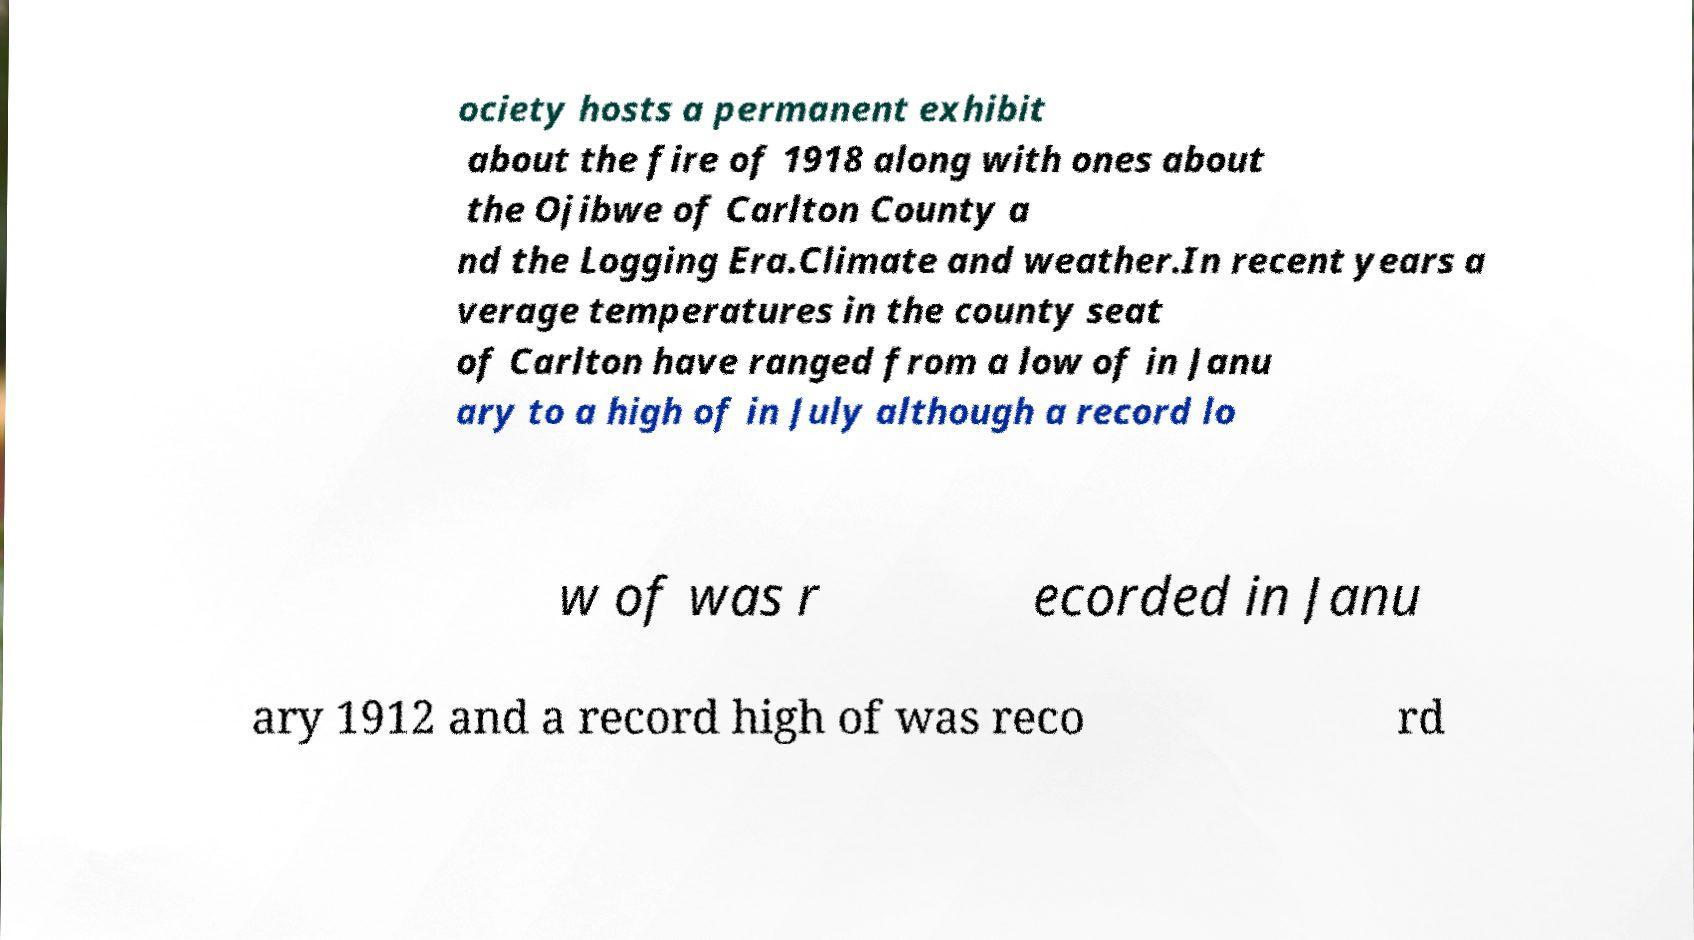Can you read and provide the text displayed in the image?This photo seems to have some interesting text. Can you extract and type it out for me? ociety hosts a permanent exhibit about the fire of 1918 along with ones about the Ojibwe of Carlton County a nd the Logging Era.Climate and weather.In recent years a verage temperatures in the county seat of Carlton have ranged from a low of in Janu ary to a high of in July although a record lo w of was r ecorded in Janu ary 1912 and a record high of was reco rd 